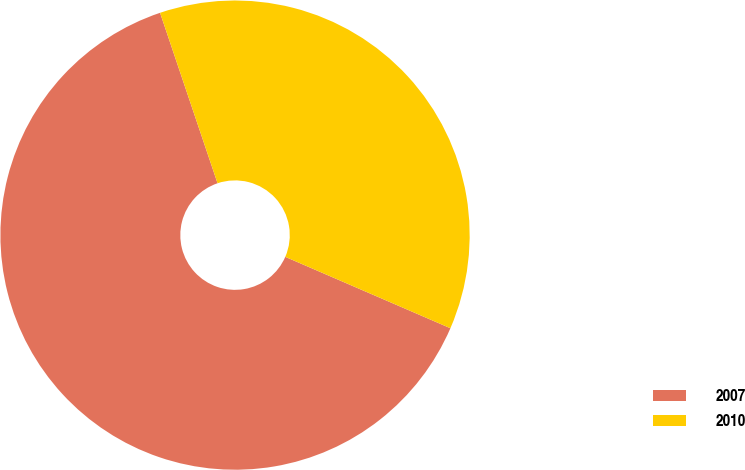Convert chart. <chart><loc_0><loc_0><loc_500><loc_500><pie_chart><fcel>2007<fcel>2010<nl><fcel>63.33%<fcel>36.67%<nl></chart> 